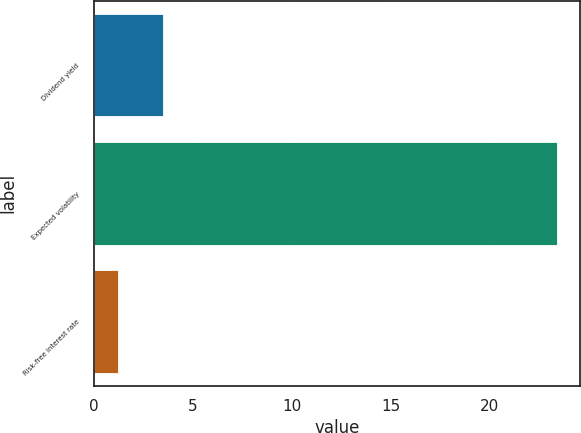Convert chart to OTSL. <chart><loc_0><loc_0><loc_500><loc_500><bar_chart><fcel>Dividend yield<fcel>Expected volatility<fcel>Risk-free interest rate<nl><fcel>3.5<fcel>23.4<fcel>1.2<nl></chart> 